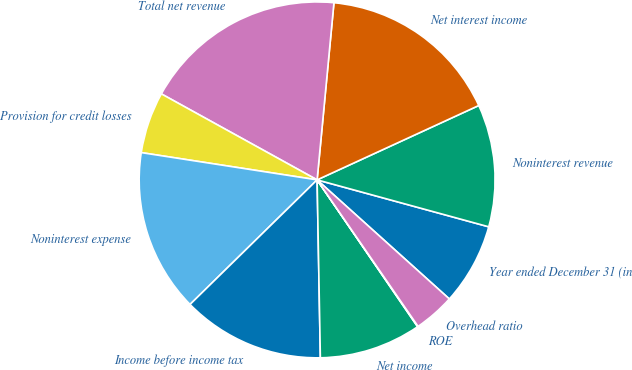Convert chart to OTSL. <chart><loc_0><loc_0><loc_500><loc_500><pie_chart><fcel>Year ended December 31 (in<fcel>Noninterest revenue<fcel>Net interest income<fcel>Total net revenue<fcel>Provision for credit losses<fcel>Noninterest expense<fcel>Income before income tax<fcel>Net income<fcel>ROE<fcel>Overhead ratio<nl><fcel>7.42%<fcel>11.11%<fcel>16.63%<fcel>18.48%<fcel>5.58%<fcel>14.79%<fcel>12.95%<fcel>9.26%<fcel>0.05%<fcel>3.73%<nl></chart> 